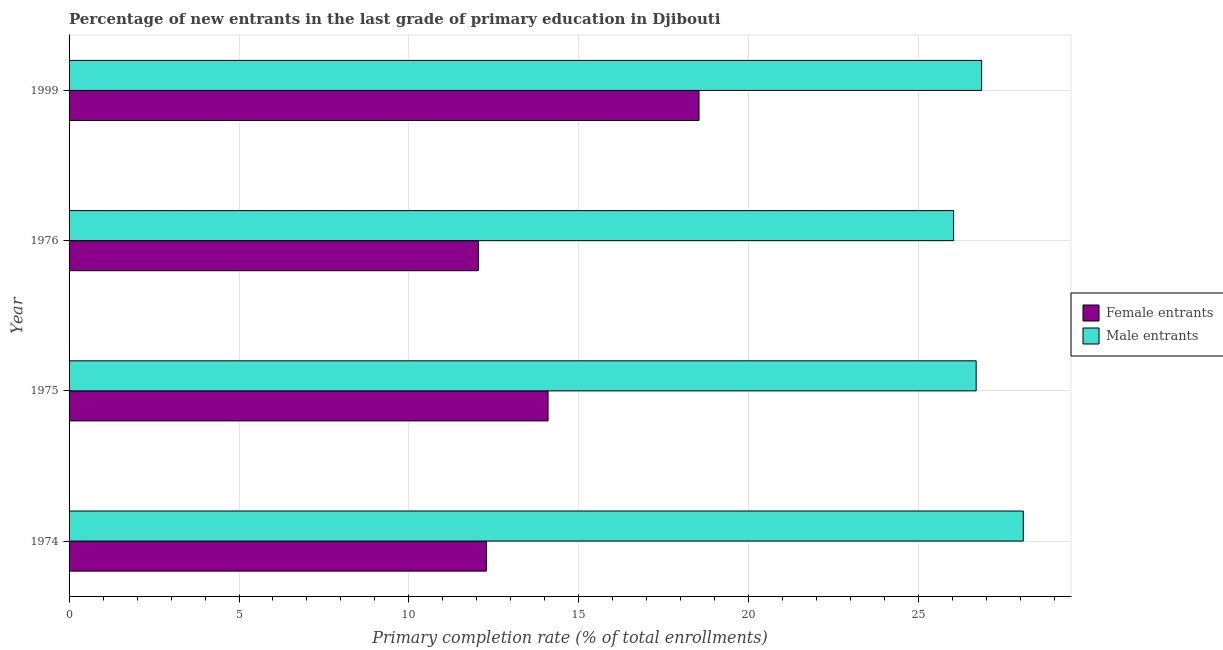How many different coloured bars are there?
Your response must be concise. 2. Are the number of bars per tick equal to the number of legend labels?
Offer a very short reply. Yes. Are the number of bars on each tick of the Y-axis equal?
Offer a very short reply. Yes. What is the label of the 1st group of bars from the top?
Offer a terse response. 1999. In how many cases, is the number of bars for a given year not equal to the number of legend labels?
Your answer should be compact. 0. What is the primary completion rate of male entrants in 1975?
Your answer should be compact. 26.69. Across all years, what is the maximum primary completion rate of male entrants?
Provide a short and direct response. 28.08. Across all years, what is the minimum primary completion rate of female entrants?
Your response must be concise. 12.04. In which year was the primary completion rate of female entrants minimum?
Offer a very short reply. 1976. What is the total primary completion rate of male entrants in the graph?
Provide a short and direct response. 107.64. What is the difference between the primary completion rate of male entrants in 1976 and that in 1999?
Ensure brevity in your answer.  -0.82. What is the difference between the primary completion rate of male entrants in 1975 and the primary completion rate of female entrants in 1974?
Offer a very short reply. 14.41. What is the average primary completion rate of male entrants per year?
Your answer should be very brief. 26.91. In the year 1999, what is the difference between the primary completion rate of female entrants and primary completion rate of male entrants?
Give a very brief answer. -8.32. What is the ratio of the primary completion rate of male entrants in 1975 to that in 1976?
Offer a terse response. 1.02. What is the difference between the highest and the second highest primary completion rate of female entrants?
Give a very brief answer. 4.44. What is the difference between the highest and the lowest primary completion rate of female entrants?
Your answer should be very brief. 6.49. What does the 2nd bar from the top in 1999 represents?
Ensure brevity in your answer.  Female entrants. What does the 2nd bar from the bottom in 1975 represents?
Provide a short and direct response. Male entrants. How many bars are there?
Keep it short and to the point. 8. Are the values on the major ticks of X-axis written in scientific E-notation?
Your answer should be very brief. No. Does the graph contain any zero values?
Offer a terse response. No. How are the legend labels stacked?
Ensure brevity in your answer.  Vertical. What is the title of the graph?
Provide a short and direct response. Percentage of new entrants in the last grade of primary education in Djibouti. Does "ODA received" appear as one of the legend labels in the graph?
Ensure brevity in your answer.  No. What is the label or title of the X-axis?
Give a very brief answer. Primary completion rate (% of total enrollments). What is the label or title of the Y-axis?
Give a very brief answer. Year. What is the Primary completion rate (% of total enrollments) in Female entrants in 1974?
Your answer should be compact. 12.28. What is the Primary completion rate (% of total enrollments) in Male entrants in 1974?
Your answer should be very brief. 28.08. What is the Primary completion rate (% of total enrollments) of Female entrants in 1975?
Make the answer very short. 14.09. What is the Primary completion rate (% of total enrollments) in Male entrants in 1975?
Provide a short and direct response. 26.69. What is the Primary completion rate (% of total enrollments) of Female entrants in 1976?
Offer a terse response. 12.04. What is the Primary completion rate (% of total enrollments) in Male entrants in 1976?
Provide a succinct answer. 26.03. What is the Primary completion rate (% of total enrollments) of Female entrants in 1999?
Offer a very short reply. 18.54. What is the Primary completion rate (% of total enrollments) in Male entrants in 1999?
Keep it short and to the point. 26.85. Across all years, what is the maximum Primary completion rate (% of total enrollments) of Female entrants?
Your answer should be compact. 18.54. Across all years, what is the maximum Primary completion rate (% of total enrollments) of Male entrants?
Give a very brief answer. 28.08. Across all years, what is the minimum Primary completion rate (% of total enrollments) of Female entrants?
Keep it short and to the point. 12.04. Across all years, what is the minimum Primary completion rate (% of total enrollments) in Male entrants?
Keep it short and to the point. 26.03. What is the total Primary completion rate (% of total enrollments) in Female entrants in the graph?
Your response must be concise. 56.95. What is the total Primary completion rate (% of total enrollments) of Male entrants in the graph?
Offer a very short reply. 107.64. What is the difference between the Primary completion rate (% of total enrollments) of Female entrants in 1974 and that in 1975?
Provide a short and direct response. -1.81. What is the difference between the Primary completion rate (% of total enrollments) of Male entrants in 1974 and that in 1975?
Offer a terse response. 1.39. What is the difference between the Primary completion rate (% of total enrollments) in Female entrants in 1974 and that in 1976?
Provide a succinct answer. 0.24. What is the difference between the Primary completion rate (% of total enrollments) of Male entrants in 1974 and that in 1976?
Provide a succinct answer. 2.05. What is the difference between the Primary completion rate (% of total enrollments) of Female entrants in 1974 and that in 1999?
Offer a terse response. -6.26. What is the difference between the Primary completion rate (% of total enrollments) in Male entrants in 1974 and that in 1999?
Your answer should be compact. 1.23. What is the difference between the Primary completion rate (% of total enrollments) of Female entrants in 1975 and that in 1976?
Give a very brief answer. 2.05. What is the difference between the Primary completion rate (% of total enrollments) of Male entrants in 1975 and that in 1976?
Keep it short and to the point. 0.66. What is the difference between the Primary completion rate (% of total enrollments) in Female entrants in 1975 and that in 1999?
Provide a succinct answer. -4.44. What is the difference between the Primary completion rate (% of total enrollments) in Male entrants in 1975 and that in 1999?
Provide a succinct answer. -0.16. What is the difference between the Primary completion rate (% of total enrollments) in Female entrants in 1976 and that in 1999?
Give a very brief answer. -6.49. What is the difference between the Primary completion rate (% of total enrollments) of Male entrants in 1976 and that in 1999?
Make the answer very short. -0.82. What is the difference between the Primary completion rate (% of total enrollments) in Female entrants in 1974 and the Primary completion rate (% of total enrollments) in Male entrants in 1975?
Make the answer very short. -14.41. What is the difference between the Primary completion rate (% of total enrollments) of Female entrants in 1974 and the Primary completion rate (% of total enrollments) of Male entrants in 1976?
Your answer should be very brief. -13.75. What is the difference between the Primary completion rate (% of total enrollments) of Female entrants in 1974 and the Primary completion rate (% of total enrollments) of Male entrants in 1999?
Provide a succinct answer. -14.57. What is the difference between the Primary completion rate (% of total enrollments) in Female entrants in 1975 and the Primary completion rate (% of total enrollments) in Male entrants in 1976?
Your answer should be very brief. -11.93. What is the difference between the Primary completion rate (% of total enrollments) of Female entrants in 1975 and the Primary completion rate (% of total enrollments) of Male entrants in 1999?
Provide a short and direct response. -12.76. What is the difference between the Primary completion rate (% of total enrollments) in Female entrants in 1976 and the Primary completion rate (% of total enrollments) in Male entrants in 1999?
Provide a succinct answer. -14.81. What is the average Primary completion rate (% of total enrollments) of Female entrants per year?
Your response must be concise. 14.24. What is the average Primary completion rate (% of total enrollments) in Male entrants per year?
Your answer should be very brief. 26.91. In the year 1974, what is the difference between the Primary completion rate (% of total enrollments) of Female entrants and Primary completion rate (% of total enrollments) of Male entrants?
Make the answer very short. -15.8. In the year 1975, what is the difference between the Primary completion rate (% of total enrollments) in Female entrants and Primary completion rate (% of total enrollments) in Male entrants?
Offer a terse response. -12.6. In the year 1976, what is the difference between the Primary completion rate (% of total enrollments) in Female entrants and Primary completion rate (% of total enrollments) in Male entrants?
Your response must be concise. -13.98. In the year 1999, what is the difference between the Primary completion rate (% of total enrollments) of Female entrants and Primary completion rate (% of total enrollments) of Male entrants?
Your answer should be compact. -8.32. What is the ratio of the Primary completion rate (% of total enrollments) in Female entrants in 1974 to that in 1975?
Keep it short and to the point. 0.87. What is the ratio of the Primary completion rate (% of total enrollments) of Male entrants in 1974 to that in 1975?
Your answer should be very brief. 1.05. What is the ratio of the Primary completion rate (% of total enrollments) in Female entrants in 1974 to that in 1976?
Give a very brief answer. 1.02. What is the ratio of the Primary completion rate (% of total enrollments) in Male entrants in 1974 to that in 1976?
Ensure brevity in your answer.  1.08. What is the ratio of the Primary completion rate (% of total enrollments) in Female entrants in 1974 to that in 1999?
Provide a short and direct response. 0.66. What is the ratio of the Primary completion rate (% of total enrollments) in Male entrants in 1974 to that in 1999?
Provide a short and direct response. 1.05. What is the ratio of the Primary completion rate (% of total enrollments) in Female entrants in 1975 to that in 1976?
Make the answer very short. 1.17. What is the ratio of the Primary completion rate (% of total enrollments) of Male entrants in 1975 to that in 1976?
Provide a short and direct response. 1.03. What is the ratio of the Primary completion rate (% of total enrollments) of Female entrants in 1975 to that in 1999?
Your response must be concise. 0.76. What is the ratio of the Primary completion rate (% of total enrollments) of Female entrants in 1976 to that in 1999?
Keep it short and to the point. 0.65. What is the ratio of the Primary completion rate (% of total enrollments) in Male entrants in 1976 to that in 1999?
Offer a very short reply. 0.97. What is the difference between the highest and the second highest Primary completion rate (% of total enrollments) of Female entrants?
Your answer should be compact. 4.44. What is the difference between the highest and the second highest Primary completion rate (% of total enrollments) of Male entrants?
Provide a short and direct response. 1.23. What is the difference between the highest and the lowest Primary completion rate (% of total enrollments) in Female entrants?
Make the answer very short. 6.49. What is the difference between the highest and the lowest Primary completion rate (% of total enrollments) of Male entrants?
Offer a terse response. 2.05. 